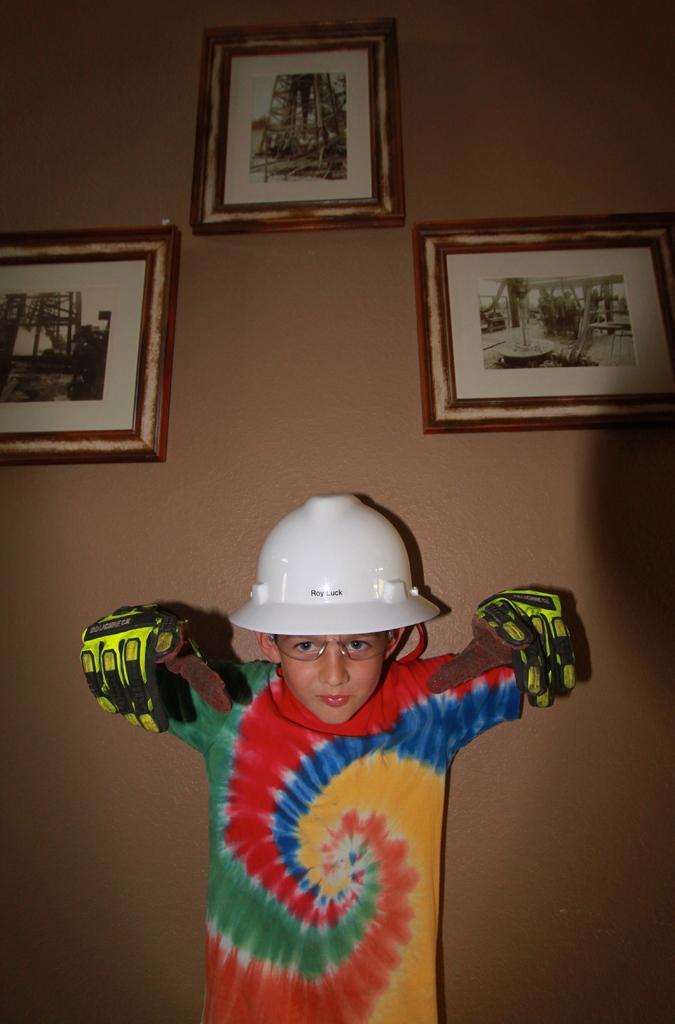In one or two sentences, can you explain what this image depicts? In this image there is a boy standing towards the bottom of the image, he is wearing gloves, he is wearing spectacles, he is wearing a helmet, at the background of the image there is a wall, there are photo frames on the wall. 